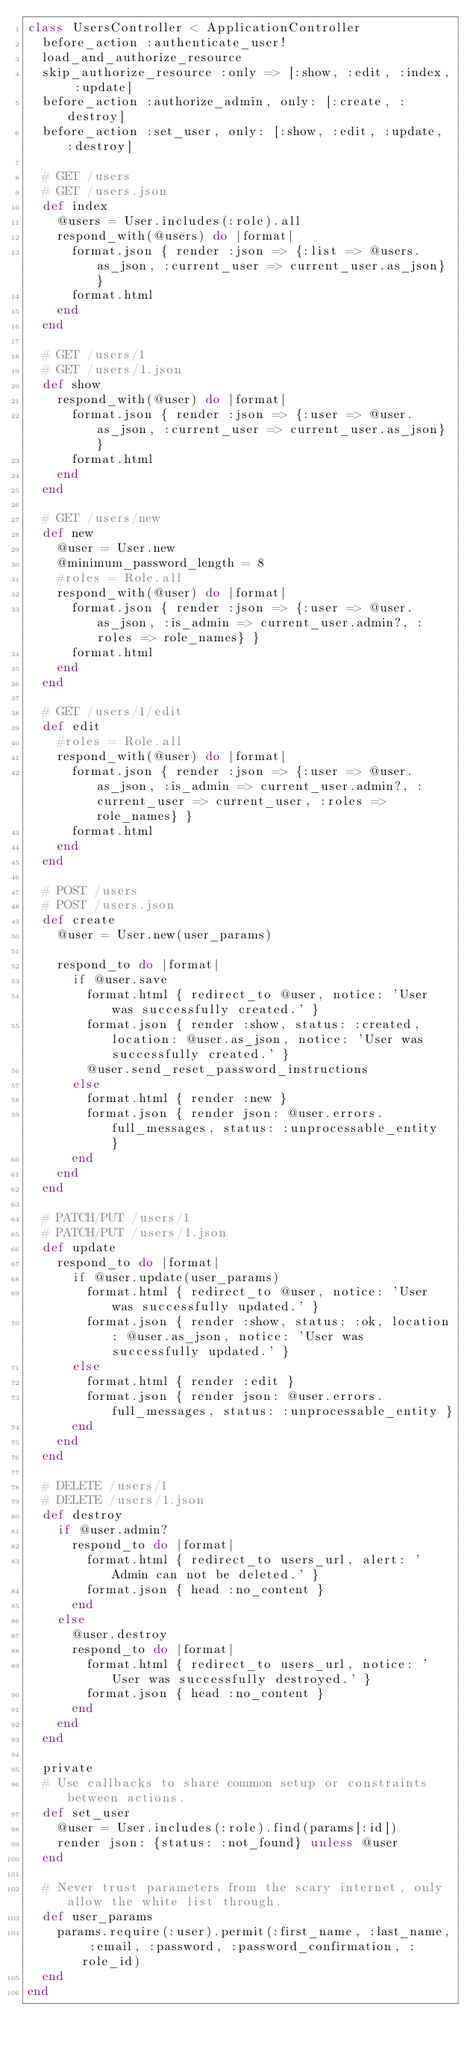Convert code to text. <code><loc_0><loc_0><loc_500><loc_500><_Ruby_>class UsersController < ApplicationController
  before_action :authenticate_user!
  load_and_authorize_resource
  skip_authorize_resource :only => [:show, :edit, :index, :update]
  before_action :authorize_admin, only: [:create, :destroy]
  before_action :set_user, only: [:show, :edit, :update, :destroy]

  # GET /users
  # GET /users.json
  def index
    @users = User.includes(:role).all
    respond_with(@users) do |format|
      format.json { render :json => {:list => @users.as_json, :current_user => current_user.as_json} }
      format.html
    end
  end

  # GET /users/1
  # GET /users/1.json
  def show
    respond_with(@user) do |format|
      format.json { render :json => {:user => @user.as_json, :current_user => current_user.as_json} }
      format.html
    end
  end

  # GET /users/new
  def new
    @user = User.new
    @minimum_password_length = 8
    #roles = Role.all
    respond_with(@user) do |format|
      format.json { render :json => {:user => @user.as_json, :is_admin => current_user.admin?, :roles => role_names} }
      format.html
    end
  end

  # GET /users/1/edit
  def edit
    #roles = Role.all
    respond_with(@user) do |format|
      format.json { render :json => {:user => @user.as_json, :is_admin => current_user.admin?, :current_user => current_user, :roles => role_names} }
      format.html
    end
  end

  # POST /users
  # POST /users.json
  def create
    @user = User.new(user_params)

    respond_to do |format|
      if @user.save
        format.html { redirect_to @user, notice: 'User was successfully created.' }
        format.json { render :show, status: :created, location: @user.as_json, notice: 'User was successfully created.' }
        @user.send_reset_password_instructions
      else
        format.html { render :new }
        format.json { render json: @user.errors.full_messages, status: :unprocessable_entity  }
      end
    end
  end

  # PATCH/PUT /users/1
  # PATCH/PUT /users/1.json
  def update
    respond_to do |format|
      if @user.update(user_params)
        format.html { redirect_to @user, notice: 'User was successfully updated.' }
        format.json { render :show, status: :ok, location: @user.as_json, notice: 'User was successfully updated.' }
      else
        format.html { render :edit }
        format.json { render json: @user.errors.full_messages, status: :unprocessable_entity }
      end
    end
  end

  # DELETE /users/1
  # DELETE /users/1.json
  def destroy
    if @user.admin?
      respond_to do |format|
        format.html { redirect_to users_url, alert: 'Admin can not be deleted.' }
        format.json { head :no_content }
      end
    else
      @user.destroy
      respond_to do |format|
        format.html { redirect_to users_url, notice: 'User was successfully destroyed.' }
        format.json { head :no_content }
      end
    end
  end

  private
  # Use callbacks to share common setup or constraints between actions.
  def set_user
    @user = User.includes(:role).find(params[:id])
    render json: {status: :not_found} unless @user
  end

  # Never trust parameters from the scary internet, only allow the white list through.
  def user_params
    params.require(:user).permit(:first_name, :last_name, :email, :password, :password_confirmation, :role_id)
  end
end
</code> 